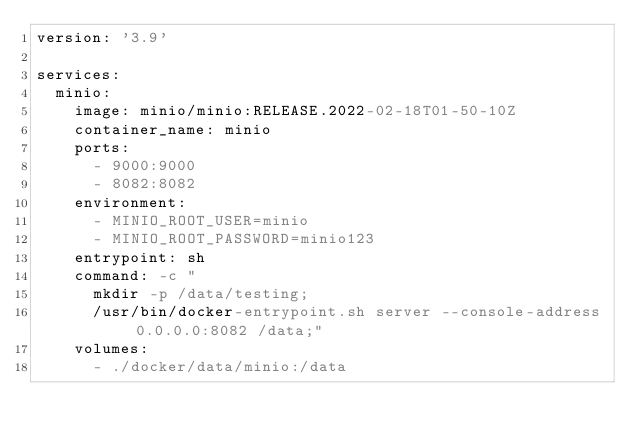Convert code to text. <code><loc_0><loc_0><loc_500><loc_500><_YAML_>version: '3.9'

services:
  minio:
    image: minio/minio:RELEASE.2022-02-18T01-50-10Z
    container_name: minio
    ports:
      - 9000:9000
      - 8082:8082
    environment:
      - MINIO_ROOT_USER=minio
      - MINIO_ROOT_PASSWORD=minio123
    entrypoint: sh
    command: -c "
      mkdir -p /data/testing;
      /usr/bin/docker-entrypoint.sh server --console-address 0.0.0.0:8082 /data;"
    volumes:
      - ./docker/data/minio:/data
</code> 